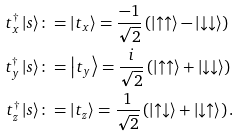<formula> <loc_0><loc_0><loc_500><loc_500>t ^ { \dagger } _ { x } \left | s \right \rangle & \colon = \left | t _ { x } \right \rangle = \frac { - 1 } { \sqrt { 2 } } \left ( \left | \uparrow \uparrow \right \rangle - \left | \downarrow \downarrow \right \rangle \right ) \\ t ^ { \dagger } _ { y } \left | s \right \rangle & \colon = \left | t _ { y } \right \rangle = \frac { i } { \sqrt { 2 } } \left ( \left | \uparrow \uparrow \right \rangle + \left | \downarrow \downarrow \right \rangle \right ) \\ t ^ { \dagger } _ { z } \left | s \right \rangle & \colon = \left | t _ { z } \right \rangle = \frac { 1 } { \sqrt { 2 } } \left ( \left | \uparrow \downarrow \right \rangle + \left | \downarrow \uparrow \right \rangle \right ) \text {.}</formula> 